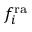<formula> <loc_0><loc_0><loc_500><loc_500>f _ { i } ^ { r a }</formula> 